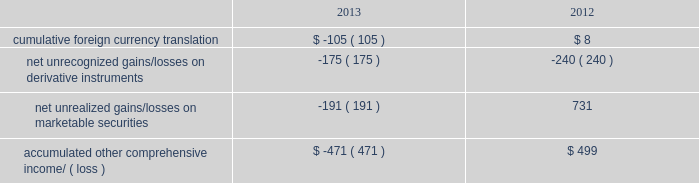Table of contents as of september 28 , 2013 .
The company 2019s share repurchase program does not obligate it to acquire any specific number of shares .
Under the program , shares may be repurchased in privately negotiated and/or open market transactions , including under plans complying with rule 10b5-1 of the securities exchange act of 1934 , as amended ( the 201cexchange act 201d ) .
In august 2012 , the company entered into an accelerated share repurchase arrangement ( 201casr 201d ) with a financial institution to purchase up to $ 1.95 billion of the company 2019s common stock in 2013 .
In the first quarter of 2013 , 2.6 million shares were initially delivered to the company .
In april 2013 , the purchase period for the asr ended and an additional 1.5 million shares were delivered to the company .
In total , 4.1 million shares were delivered under the asr at an average repurchase price of $ 478.20 per share .
The shares were retired in the quarters they were delivered , and the up-front payment of $ 1.95 billion was accounted for as a reduction to shareholders 2019 equity in the company 2019s consolidated balance sheet in the first quarter of 2013 .
In april 2013 , the company entered into a new asr program with two financial institutions to purchase up to $ 12 billion of the company 2019s common stock .
In exchange for up-front payments totaling $ 12 billion , the financial institutions committed to deliver shares during the asr 2019s purchase periods , which will end during 2014 .
The total number of shares ultimately delivered , and therefore the average price paid per share , will be determined at the end of the applicable purchase period based on the volume weighted average price of the company 2019s stock during that period .
During the third quarter of 2013 , 23.5 million shares were initially delivered to the company and retired .
This does not represent the final number of shares to be delivered under the asr .
The up-front payments of $ 12 billion were accounted for as a reduction to shareholders 2019 equity in the company 2019s consolidated balance sheet .
The company reflected the asrs as a repurchase of common stock for purposes of calculating earnings per share and as forward contracts indexed to its own common stock .
The forward contracts met all of the applicable criteria for equity classification , and , therefore , were not accounted for as derivative instruments .
During 2013 , the company repurchased 19.4 million shares of its common stock in the open market at an average price of $ 464.11 per share for a total of $ 9.0 billion .
These shares were retired upon repurchase .
Note 8 2013 comprehensive income comprehensive income consists of two components , net income and other comprehensive income .
Other comprehensive income refers to revenue , expenses , and gains and losses that under gaap are recorded as an element of shareholders 2019 equity but are excluded from net income .
The company 2019s other comprehensive income consists of foreign currency translation adjustments from those subsidiaries not using the u.s .
Dollar as their functional currency , net deferred gains and losses on certain derivative instruments accounted for as cash flow hedges , and unrealized gains and losses on marketable securities classified as available-for-sale .
The table shows the components of aoci , net of taxes , as of september 28 , 2013 and september 29 , 2012 ( in millions ) : .

What was the change in cumulative foreign currency translation during 2013? 
Computations: ((105 * const_m1) - 8)
Answer: -113.0. 